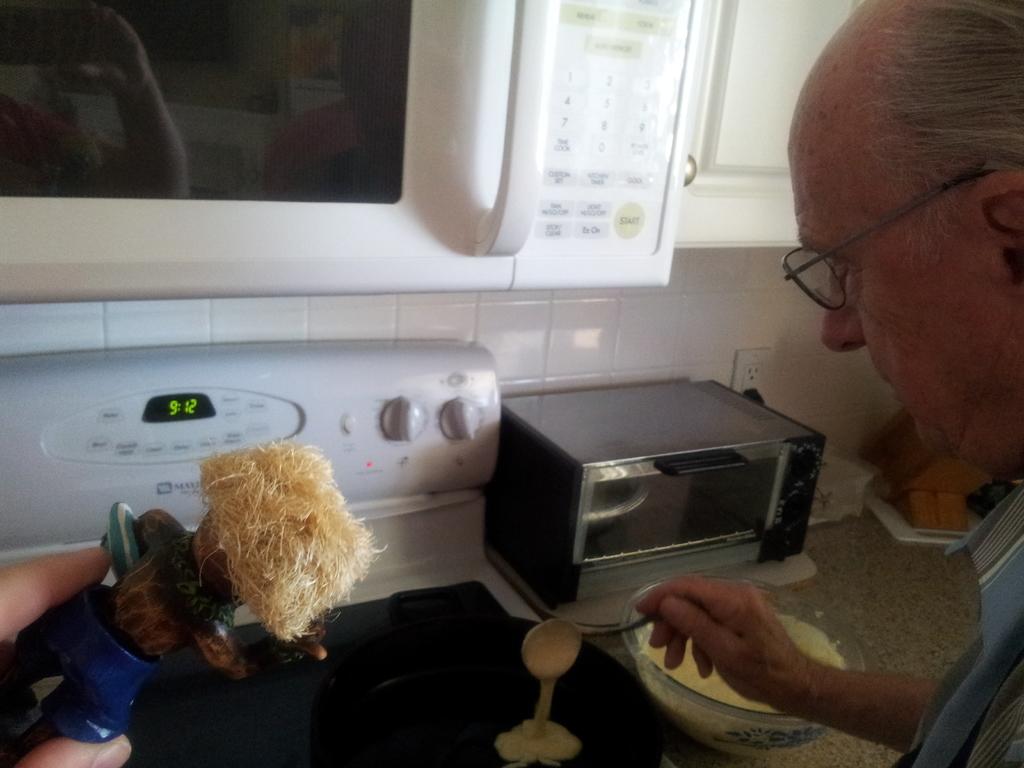What time is it?
Ensure brevity in your answer.  9:12. 